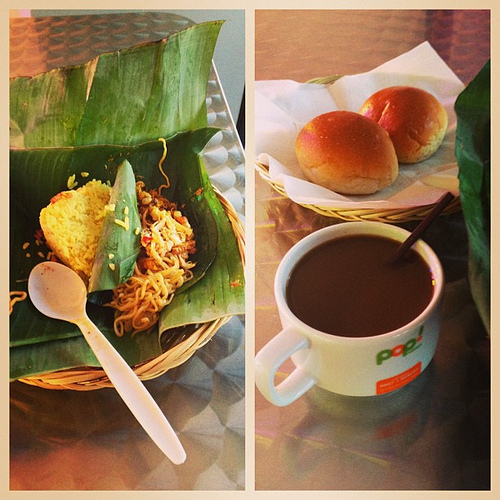In which part is the spoon?
Answer the question using a single word or phrase. Left What type of food is to the left of the mug? Noodles What is the spoon in? Basket What are the buns in? Basket What is the drink that the straw is in? Coffee The logo is on what? Mug What piece of furniture is silver? Table What is the color of the table? Silver What is the drink to the right of the food that is to the right of the food? Coffee Is the logo on the mug? Yes What is the logo on? Mug What is the spoon made of? Plastic Are there spoons or knives that are made of steel? No What food is to the left of the coffee? Noodles What food is to the left of the brown drink? Noodles What color do you think the buns in the basket are? Gold Are there any spoons to the left of the mug the coffee is in? Yes What are the noodles in? Basket What is the straw in? Coffee Is the spoon made of plastic? Yes What drink is to the right of the utensil made of plastic? Coffee What is in the basket that is on the table? Buns What kind of baked good is in the basket that is on the table? Buns What drink is to the right of the spoon? Coffee Is the coffee in the white mug? Yes 